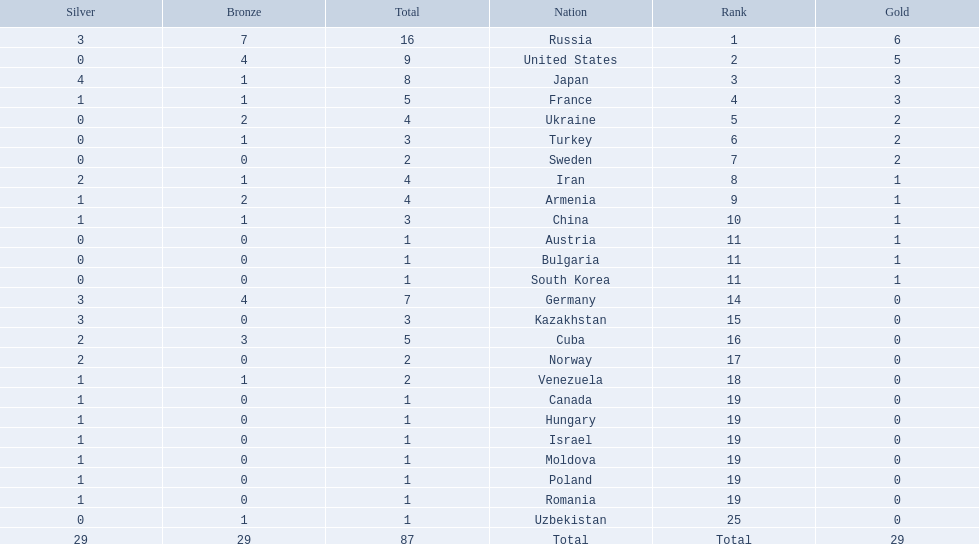Which nations participated in the championships? Russia, United States, Japan, France, Ukraine, Turkey, Sweden, Iran, Armenia, China, Austria, Bulgaria, South Korea, Germany, Kazakhstan, Cuba, Norway, Venezuela, Canada, Hungary, Israel, Moldova, Poland, Romania, Uzbekistan. How many bronze medals did they receive? 7, 4, 1, 1, 2, 1, 0, 1, 2, 1, 0, 0, 0, 4, 0, 3, 0, 1, 0, 0, 0, 0, 0, 0, 1, 29. How many in total? 16, 9, 8, 5, 4, 3, 2, 4, 4, 3, 1, 1, 1, 7, 3, 5, 2, 2, 1, 1, 1, 1, 1, 1, 1. And which team won only one medal -- the bronze? Uzbekistan. How many gold medals did the united states win? 5. Who won more than 5 gold medals? Russia. 